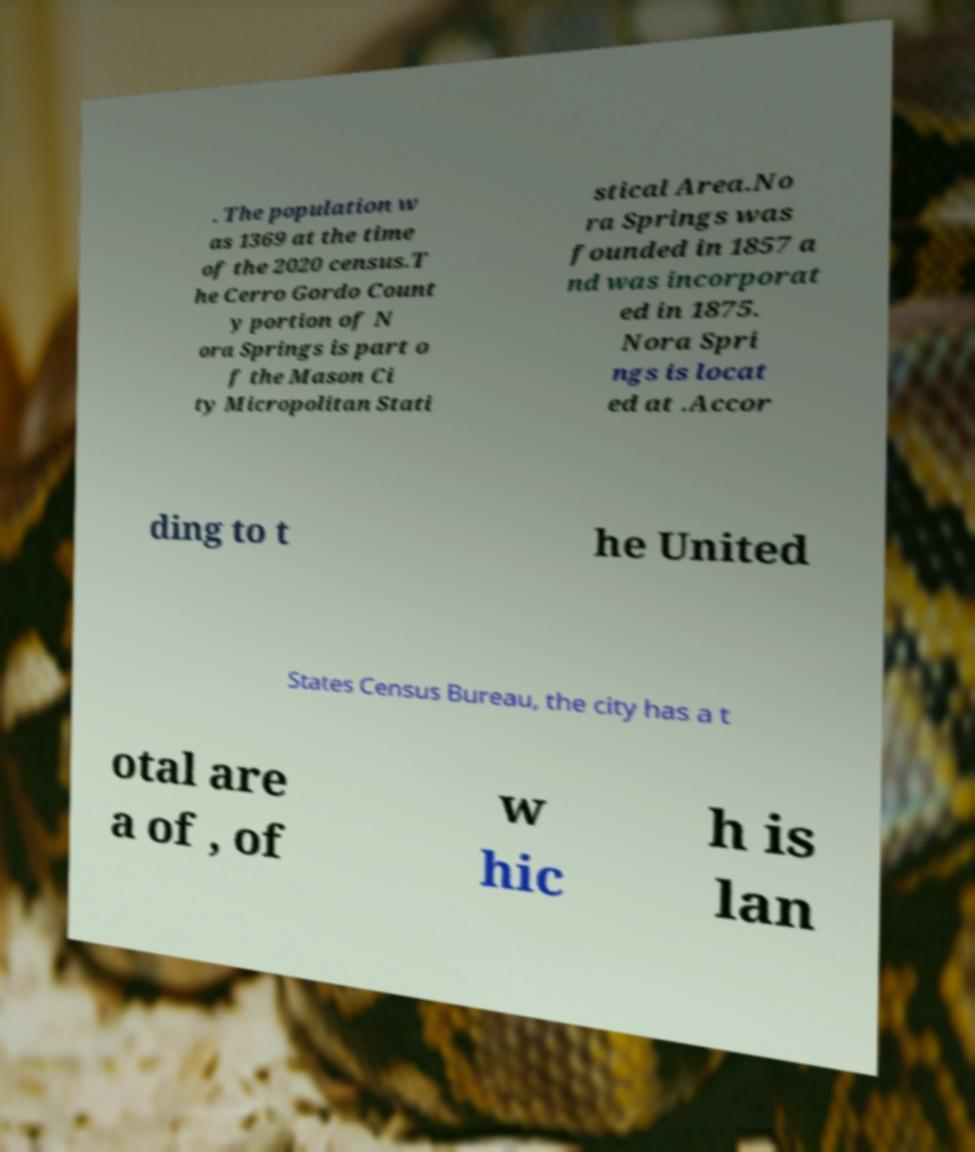Could you assist in decoding the text presented in this image and type it out clearly? . The population w as 1369 at the time of the 2020 census.T he Cerro Gordo Count y portion of N ora Springs is part o f the Mason Ci ty Micropolitan Stati stical Area.No ra Springs was founded in 1857 a nd was incorporat ed in 1875. Nora Spri ngs is locat ed at .Accor ding to t he United States Census Bureau, the city has a t otal are a of , of w hic h is lan 